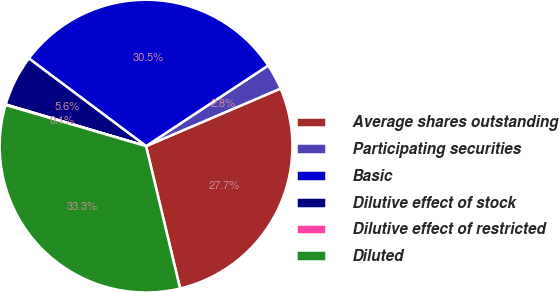<chart> <loc_0><loc_0><loc_500><loc_500><pie_chart><fcel>Average shares outstanding<fcel>Participating securities<fcel>Basic<fcel>Dilutive effect of stock<fcel>Dilutive effect of restricted<fcel>Diluted<nl><fcel>27.7%<fcel>2.85%<fcel>30.49%<fcel>5.63%<fcel>0.06%<fcel>33.27%<nl></chart> 